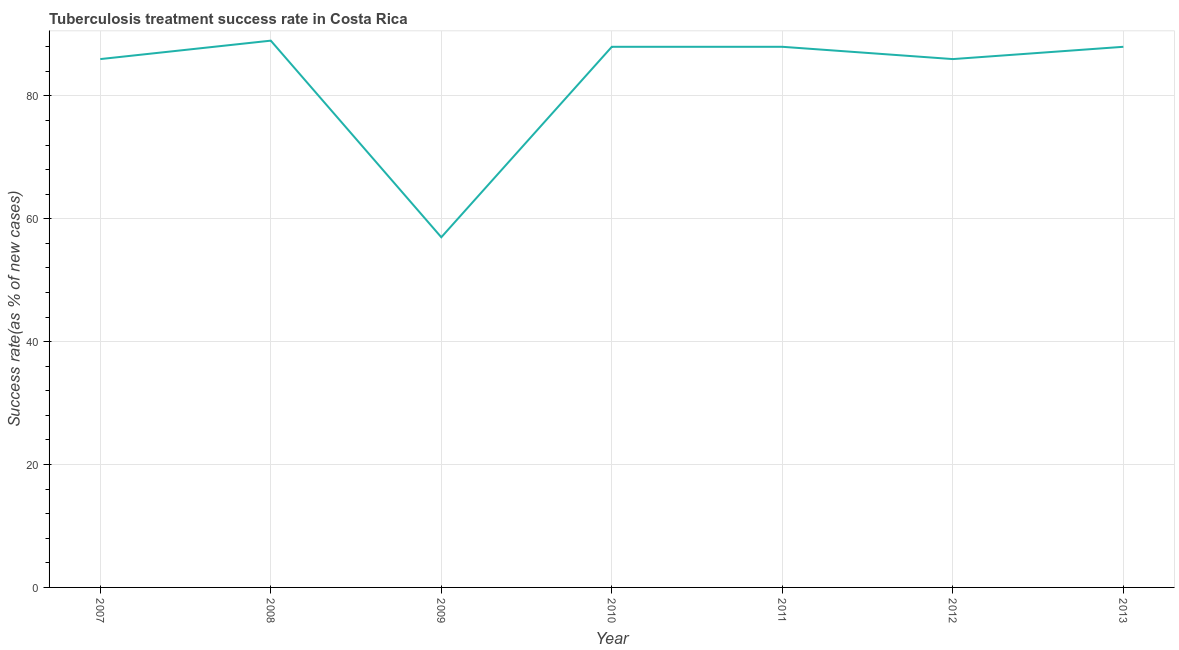What is the tuberculosis treatment success rate in 2012?
Give a very brief answer. 86. Across all years, what is the maximum tuberculosis treatment success rate?
Offer a terse response. 89. Across all years, what is the minimum tuberculosis treatment success rate?
Offer a very short reply. 57. In which year was the tuberculosis treatment success rate maximum?
Keep it short and to the point. 2008. In which year was the tuberculosis treatment success rate minimum?
Keep it short and to the point. 2009. What is the sum of the tuberculosis treatment success rate?
Provide a short and direct response. 582. What is the difference between the tuberculosis treatment success rate in 2007 and 2008?
Your answer should be compact. -3. What is the average tuberculosis treatment success rate per year?
Provide a succinct answer. 83.14. What is the median tuberculosis treatment success rate?
Give a very brief answer. 88. Do a majority of the years between 2009 and 2007 (inclusive) have tuberculosis treatment success rate greater than 4 %?
Provide a succinct answer. No. Is the difference between the tuberculosis treatment success rate in 2009 and 2013 greater than the difference between any two years?
Your response must be concise. No. What is the difference between the highest and the lowest tuberculosis treatment success rate?
Keep it short and to the point. 32. How many lines are there?
Provide a succinct answer. 1. How many years are there in the graph?
Provide a short and direct response. 7. Are the values on the major ticks of Y-axis written in scientific E-notation?
Offer a terse response. No. What is the title of the graph?
Give a very brief answer. Tuberculosis treatment success rate in Costa Rica. What is the label or title of the Y-axis?
Offer a very short reply. Success rate(as % of new cases). What is the Success rate(as % of new cases) in 2007?
Make the answer very short. 86. What is the Success rate(as % of new cases) of 2008?
Keep it short and to the point. 89. What is the Success rate(as % of new cases) of 2010?
Your answer should be compact. 88. What is the Success rate(as % of new cases) of 2011?
Your answer should be very brief. 88. What is the Success rate(as % of new cases) in 2012?
Give a very brief answer. 86. What is the Success rate(as % of new cases) in 2013?
Provide a short and direct response. 88. What is the difference between the Success rate(as % of new cases) in 2007 and 2008?
Your answer should be compact. -3. What is the difference between the Success rate(as % of new cases) in 2007 and 2009?
Offer a terse response. 29. What is the difference between the Success rate(as % of new cases) in 2007 and 2013?
Make the answer very short. -2. What is the difference between the Success rate(as % of new cases) in 2008 and 2011?
Your answer should be very brief. 1. What is the difference between the Success rate(as % of new cases) in 2008 and 2012?
Keep it short and to the point. 3. What is the difference between the Success rate(as % of new cases) in 2008 and 2013?
Provide a succinct answer. 1. What is the difference between the Success rate(as % of new cases) in 2009 and 2010?
Provide a short and direct response. -31. What is the difference between the Success rate(as % of new cases) in 2009 and 2011?
Your answer should be compact. -31. What is the difference between the Success rate(as % of new cases) in 2009 and 2013?
Provide a succinct answer. -31. What is the difference between the Success rate(as % of new cases) in 2010 and 2011?
Your answer should be very brief. 0. What is the difference between the Success rate(as % of new cases) in 2010 and 2012?
Your answer should be compact. 2. What is the difference between the Success rate(as % of new cases) in 2010 and 2013?
Offer a terse response. 0. What is the difference between the Success rate(as % of new cases) in 2011 and 2013?
Offer a terse response. 0. What is the difference between the Success rate(as % of new cases) in 2012 and 2013?
Keep it short and to the point. -2. What is the ratio of the Success rate(as % of new cases) in 2007 to that in 2008?
Offer a very short reply. 0.97. What is the ratio of the Success rate(as % of new cases) in 2007 to that in 2009?
Offer a very short reply. 1.51. What is the ratio of the Success rate(as % of new cases) in 2007 to that in 2010?
Your answer should be very brief. 0.98. What is the ratio of the Success rate(as % of new cases) in 2007 to that in 2011?
Your response must be concise. 0.98. What is the ratio of the Success rate(as % of new cases) in 2007 to that in 2012?
Provide a succinct answer. 1. What is the ratio of the Success rate(as % of new cases) in 2008 to that in 2009?
Give a very brief answer. 1.56. What is the ratio of the Success rate(as % of new cases) in 2008 to that in 2012?
Your response must be concise. 1.03. What is the ratio of the Success rate(as % of new cases) in 2009 to that in 2010?
Give a very brief answer. 0.65. What is the ratio of the Success rate(as % of new cases) in 2009 to that in 2011?
Offer a terse response. 0.65. What is the ratio of the Success rate(as % of new cases) in 2009 to that in 2012?
Keep it short and to the point. 0.66. What is the ratio of the Success rate(as % of new cases) in 2009 to that in 2013?
Your response must be concise. 0.65. What is the ratio of the Success rate(as % of new cases) in 2010 to that in 2013?
Give a very brief answer. 1. 